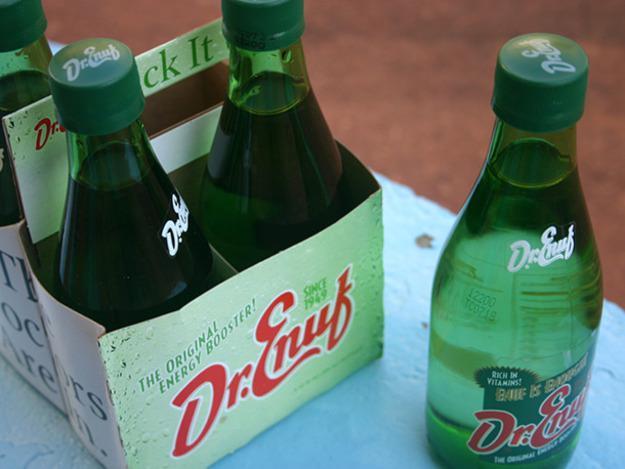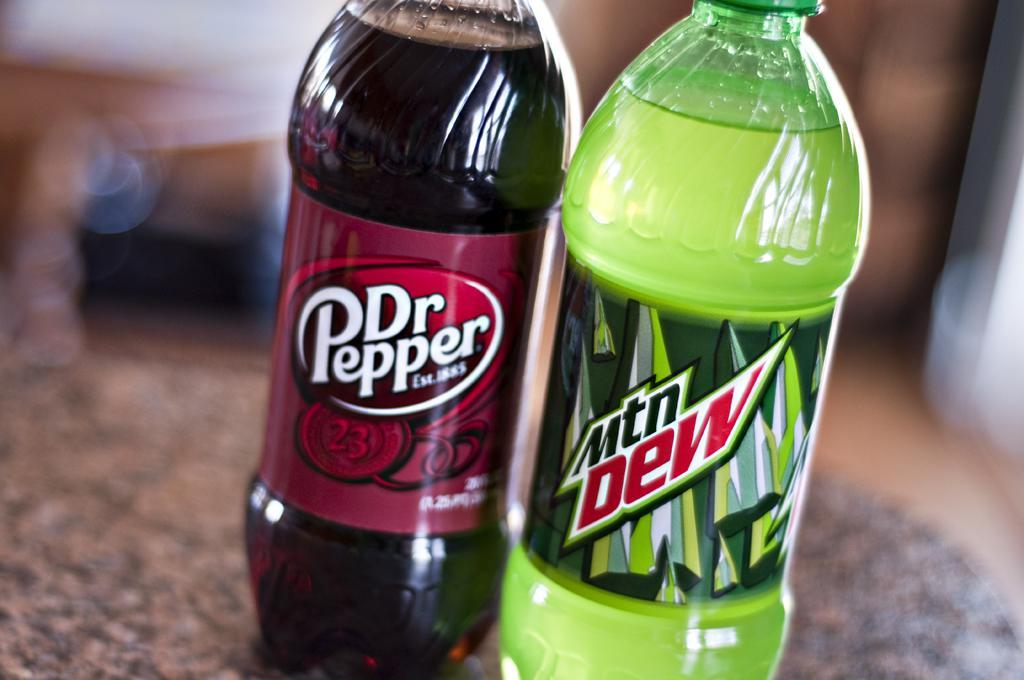The first image is the image on the left, the second image is the image on the right. Considering the images on both sides, is "The right image includes multiple bottles with the same red-and-white labels, while the left image contains no identical bottles." valid? Answer yes or no. No. The first image is the image on the left, the second image is the image on the right. Evaluate the accuracy of this statement regarding the images: "The right image contains exactly two bottles.". Is it true? Answer yes or no. Yes. 